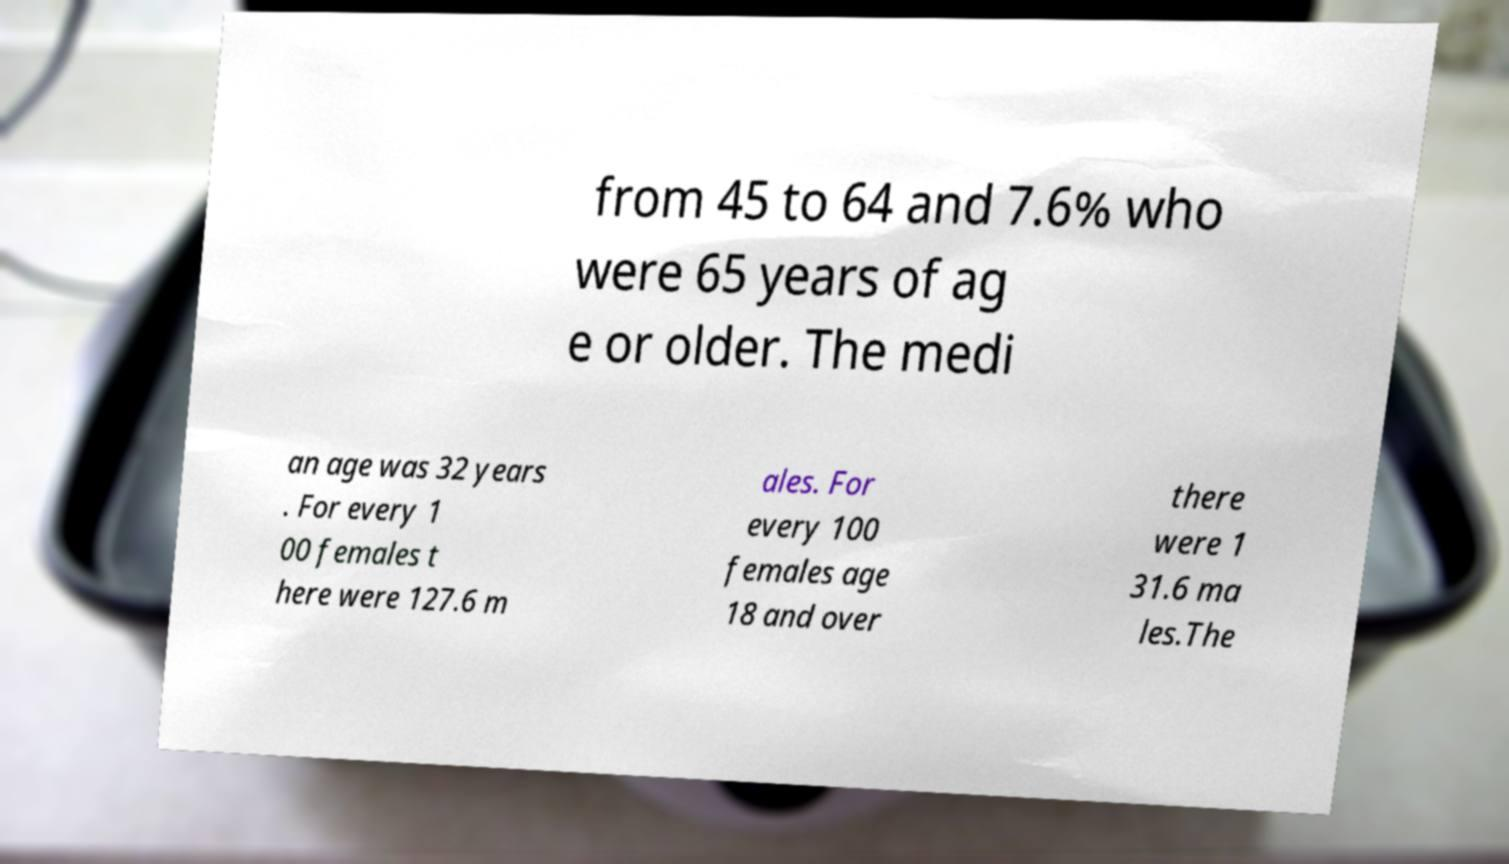Could you assist in decoding the text presented in this image and type it out clearly? from 45 to 64 and 7.6% who were 65 years of ag e or older. The medi an age was 32 years . For every 1 00 females t here were 127.6 m ales. For every 100 females age 18 and over there were 1 31.6 ma les.The 